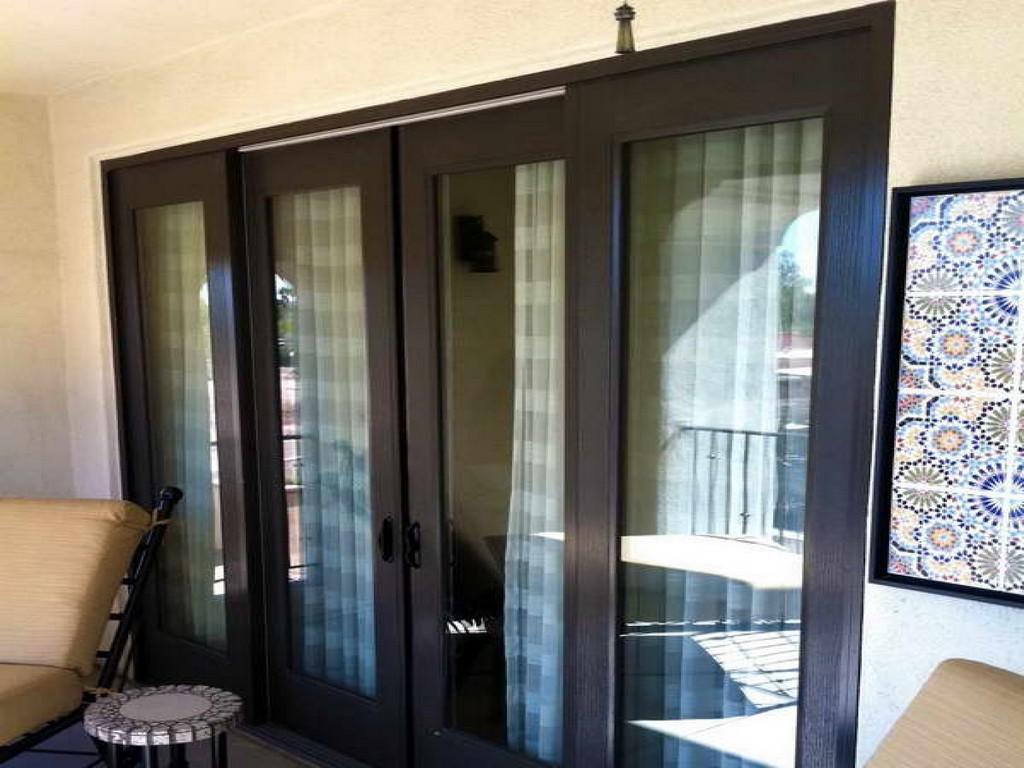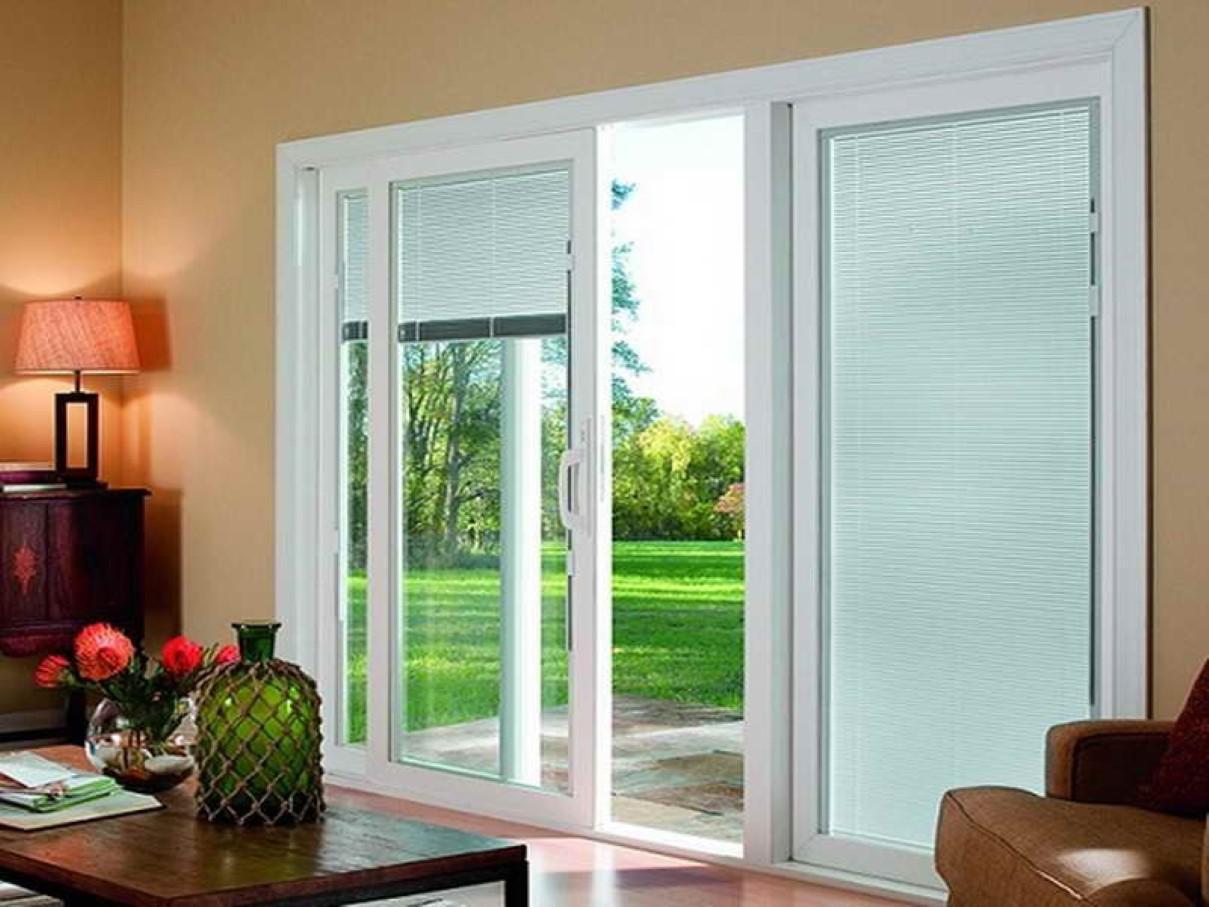The first image is the image on the left, the second image is the image on the right. Assess this claim about the two images: "One of the images has horizontal blinds on the glass doors.". Correct or not? Answer yes or no. Yes. The first image is the image on the left, the second image is the image on the right. For the images displayed, is the sentence "An image shows a rectangle with four white-framed door sections surrounded by grayish wall." factually correct? Answer yes or no. No. 